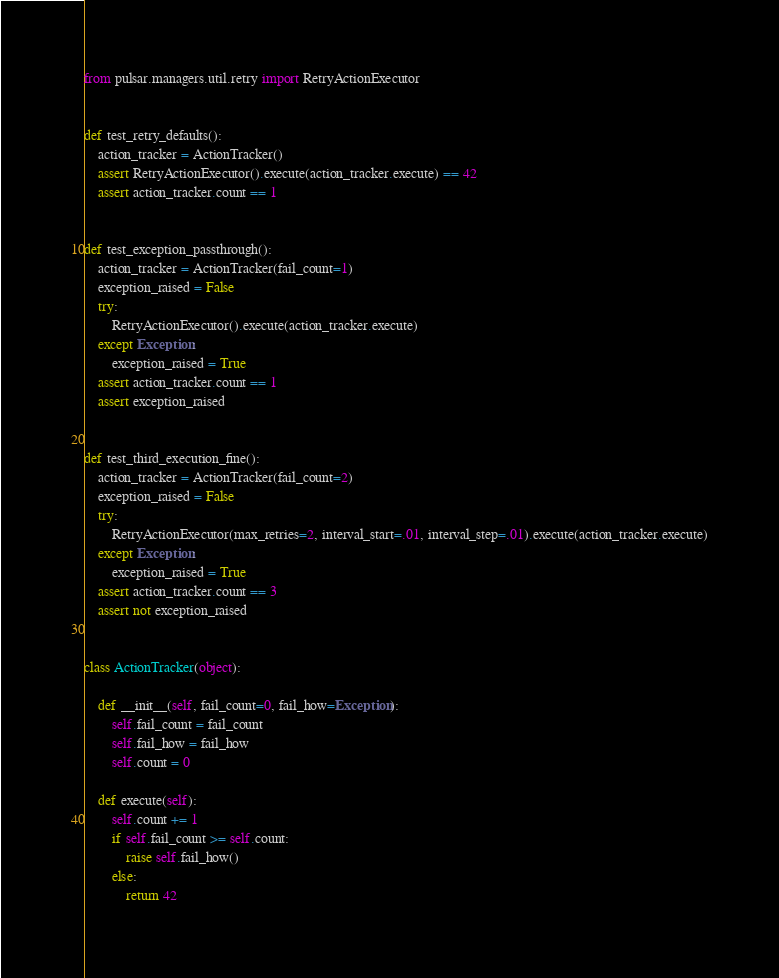Convert code to text. <code><loc_0><loc_0><loc_500><loc_500><_Python_>from pulsar.managers.util.retry import RetryActionExecutor


def test_retry_defaults():
    action_tracker = ActionTracker()
    assert RetryActionExecutor().execute(action_tracker.execute) == 42
    assert action_tracker.count == 1


def test_exception_passthrough():
    action_tracker = ActionTracker(fail_count=1)
    exception_raised = False
    try:
        RetryActionExecutor().execute(action_tracker.execute)
    except Exception:
        exception_raised = True
    assert action_tracker.count == 1
    assert exception_raised


def test_third_execution_fine():
    action_tracker = ActionTracker(fail_count=2)
    exception_raised = False
    try:
        RetryActionExecutor(max_retries=2, interval_start=.01, interval_step=.01).execute(action_tracker.execute)
    except Exception:
        exception_raised = True
    assert action_tracker.count == 3
    assert not exception_raised


class ActionTracker(object):

    def __init__(self, fail_count=0, fail_how=Exception):
        self.fail_count = fail_count
        self.fail_how = fail_how
        self.count = 0

    def execute(self):
        self.count += 1
        if self.fail_count >= self.count:
            raise self.fail_how()
        else:
            return 42
</code> 